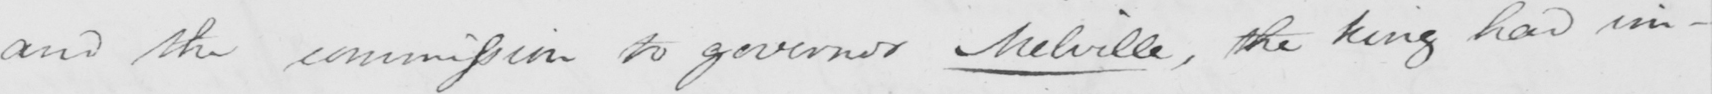What does this handwritten line say? and the commission to governor Melville , the King had im- 